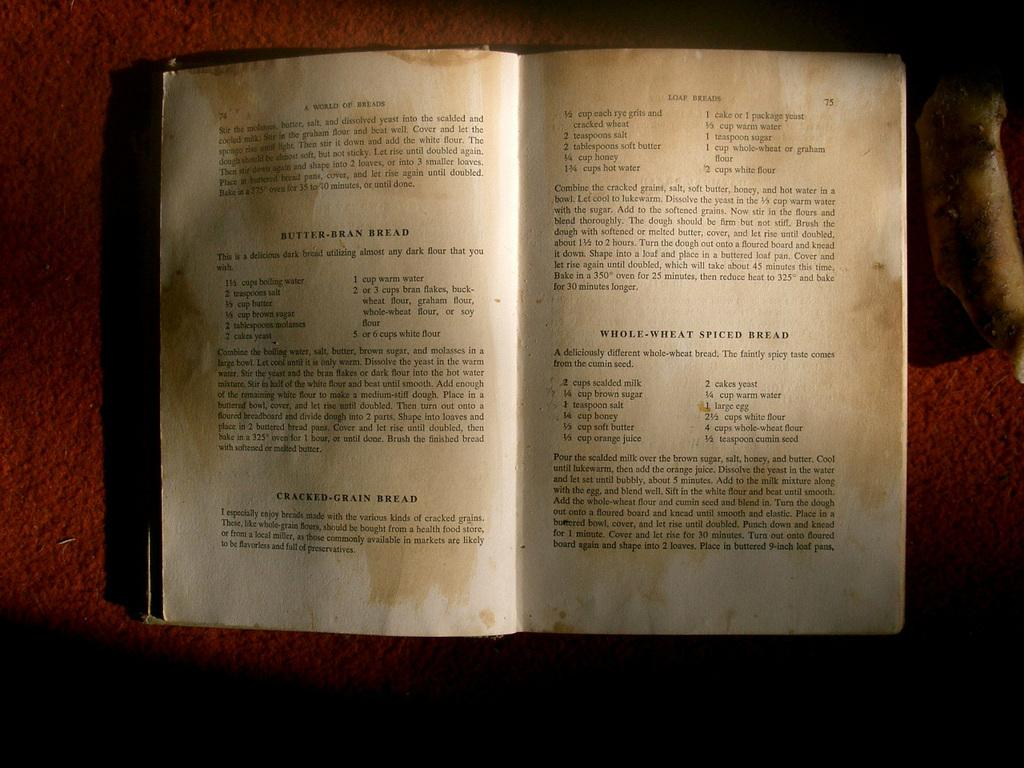<image>
Create a compact narrative representing the image presented. The book A World of Breads is open to pages showing recipes for Butter Bran Bread and Loaf Breads. 